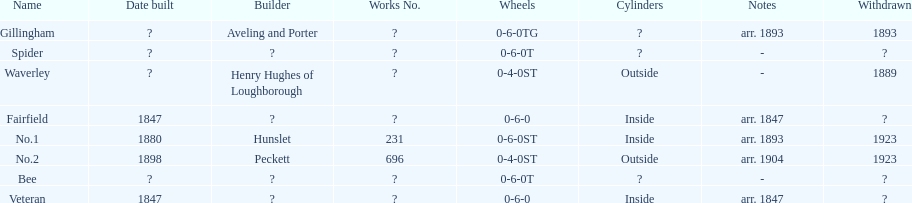Were there more with inside or outside cylinders? Inside. 